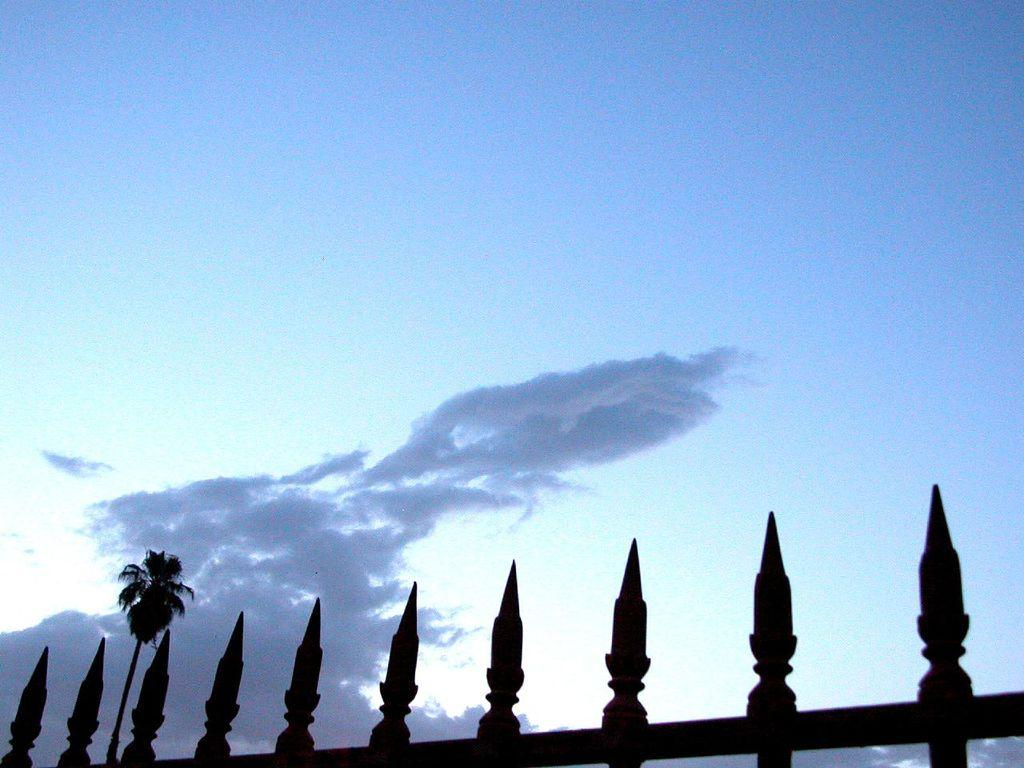What is located at the bottom of the image? There is a fence and a tree at the bottom of the image. Can you describe the sky in the background of the image? The sky in the background of the image has clouds. What scent can be detected from the flower in the image? There is no flower present in the image, so no scent can be detected. 